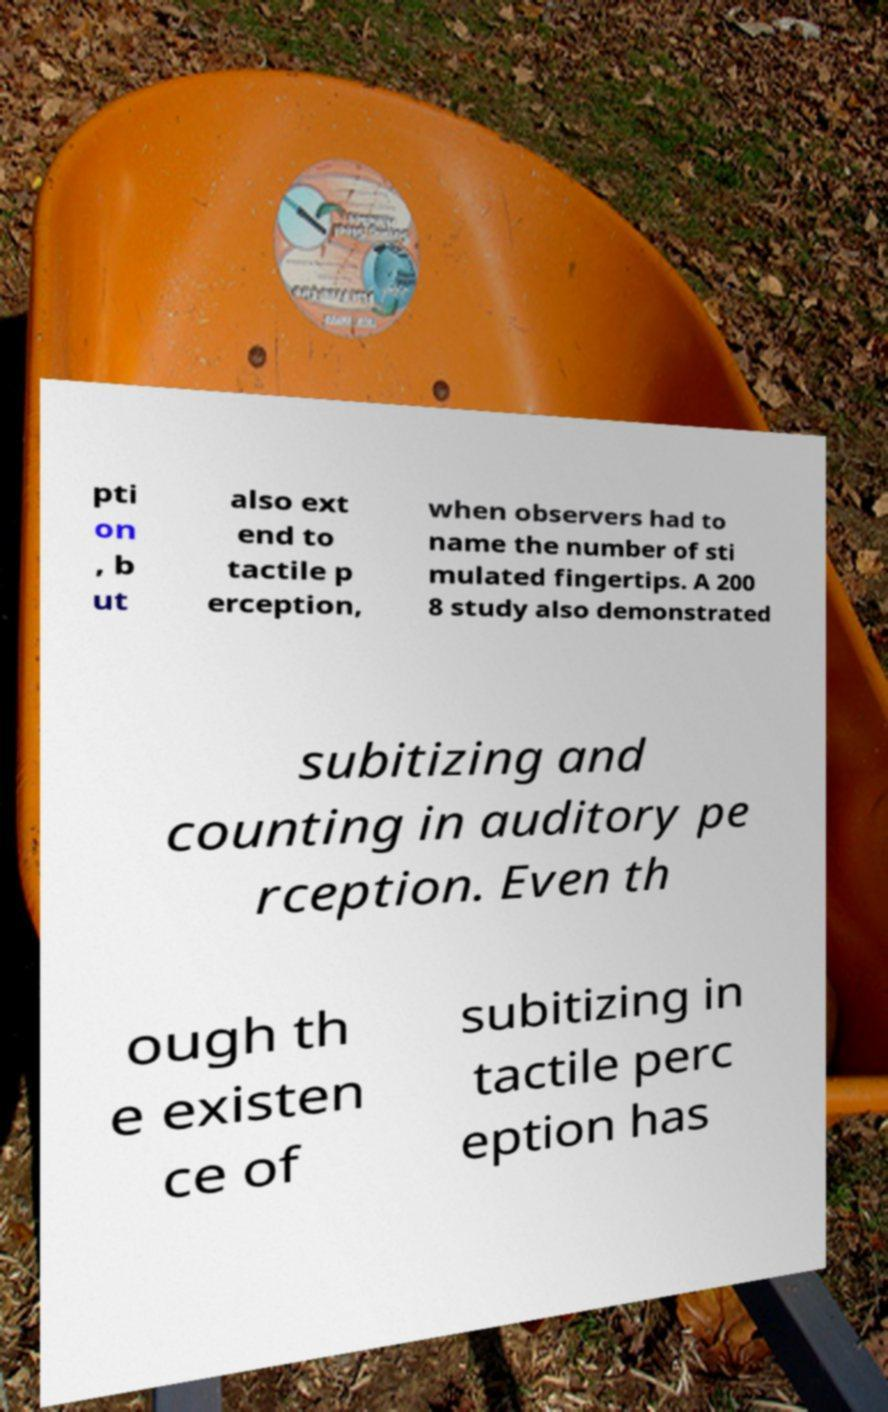Please read and relay the text visible in this image. What does it say? pti on , b ut also ext end to tactile p erception, when observers had to name the number of sti mulated fingertips. A 200 8 study also demonstrated subitizing and counting in auditory pe rception. Even th ough th e existen ce of subitizing in tactile perc eption has 